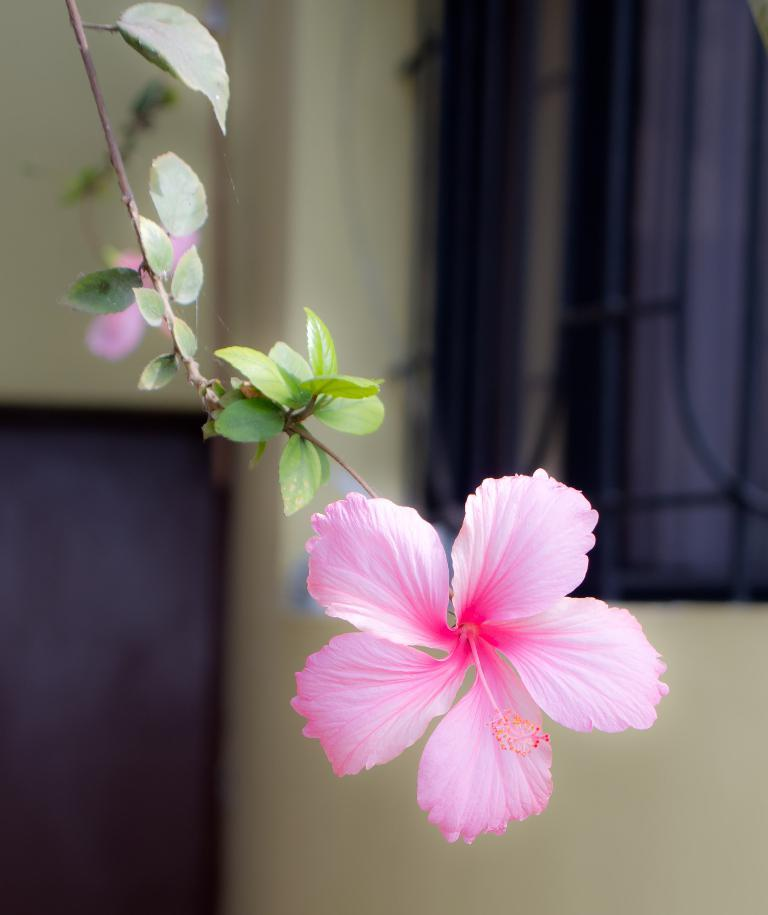What is the main subject of the image? There is a flower in the image. What can be seen on the stem of the flower? There are leaves on a stem in the image. What is visible in the background of the image? There is a window visible in the background of the image. Where is the window located in the image? The window is on a wall. What color object is on the left side of the image? There is a black color object on the left side of the image. What type of tax is being discussed in the image? There is no discussion of tax in the image; it features a flower, leaves, a window, and a black color object. What type of quartz can be seen in the image? There is no quartz present in the image. 